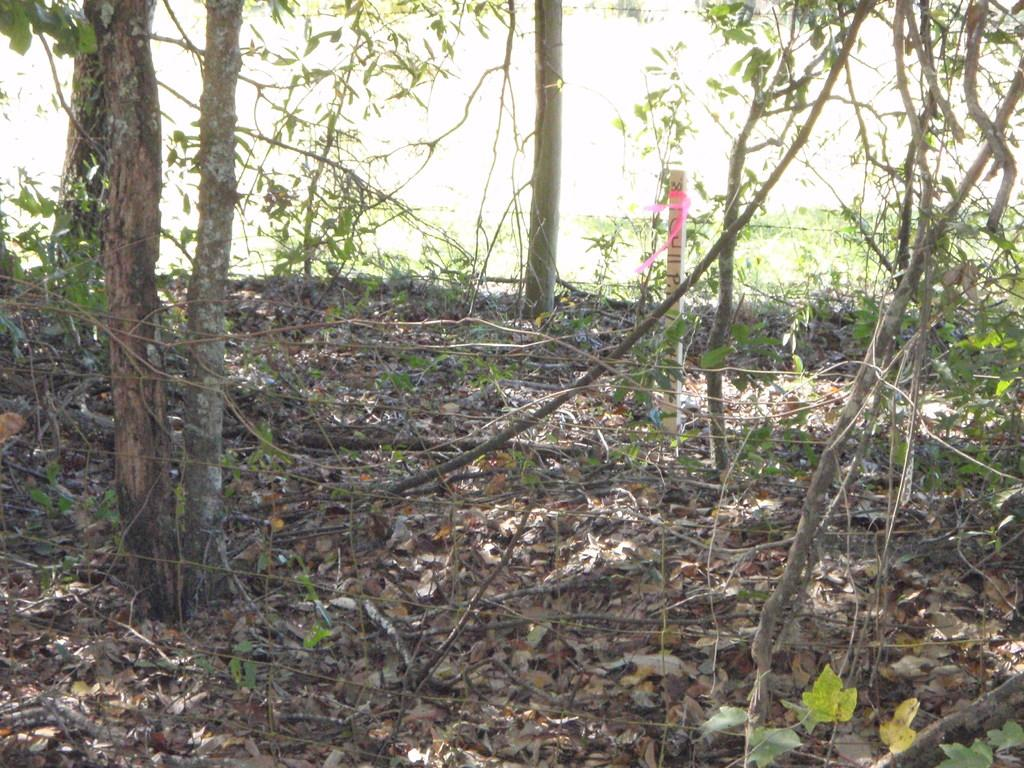What part of the trees can be seen in the image? The trunk and branches of trees are visible in the image. What is present on the ground in the image? Leaves are visible on the ground in the image. What type of church can be seen in the middle of the image? There is no church present in the image; it features trees and their trunks, branches, and leaves on the ground. Can you describe the squirrel sitting on the branch in the image? There is no squirrel present in the image; it only features trees and their components. 